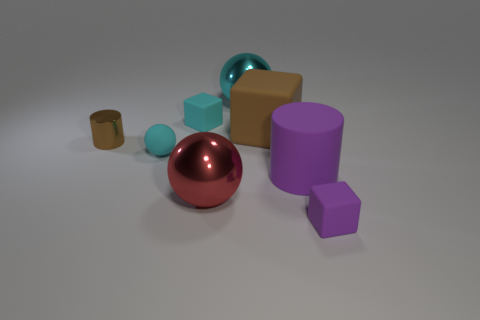There is a brown object that is the same size as the cyan shiny object; what material is it?
Give a very brief answer. Rubber. What size is the cyan matte object in front of the tiny brown shiny thing?
Give a very brief answer. Small. What is the size of the purple cube?
Offer a terse response. Small. Do the cyan block and the block in front of the big cube have the same size?
Your response must be concise. Yes. There is a tiny rubber block that is on the left side of the ball that is behind the rubber ball; what is its color?
Provide a short and direct response. Cyan. Are there the same number of cylinders behind the large cube and big purple matte objects that are in front of the large purple matte cylinder?
Your answer should be very brief. Yes. Is the material of the purple object left of the small purple cube the same as the brown block?
Ensure brevity in your answer.  Yes. What color is the small thing that is both on the right side of the tiny ball and in front of the brown metallic cylinder?
Give a very brief answer. Purple. How many things are behind the small cyan thing behind the small cyan sphere?
Offer a terse response. 1. What material is the other tiny object that is the same shape as the cyan metal thing?
Ensure brevity in your answer.  Rubber. 